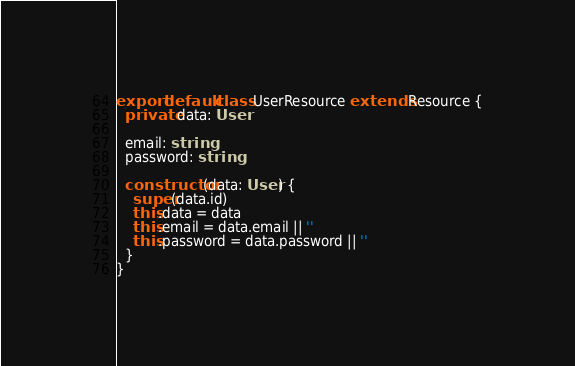<code> <loc_0><loc_0><loc_500><loc_500><_TypeScript_>
export default class UserResource extends Resource {
  private data: User

  email: string
  password: string

  constructor(data: User) {
    super(data.id)
    this.data = data
    this.email = data.email || ''
    this.password = data.password || ''
  }
}
</code> 